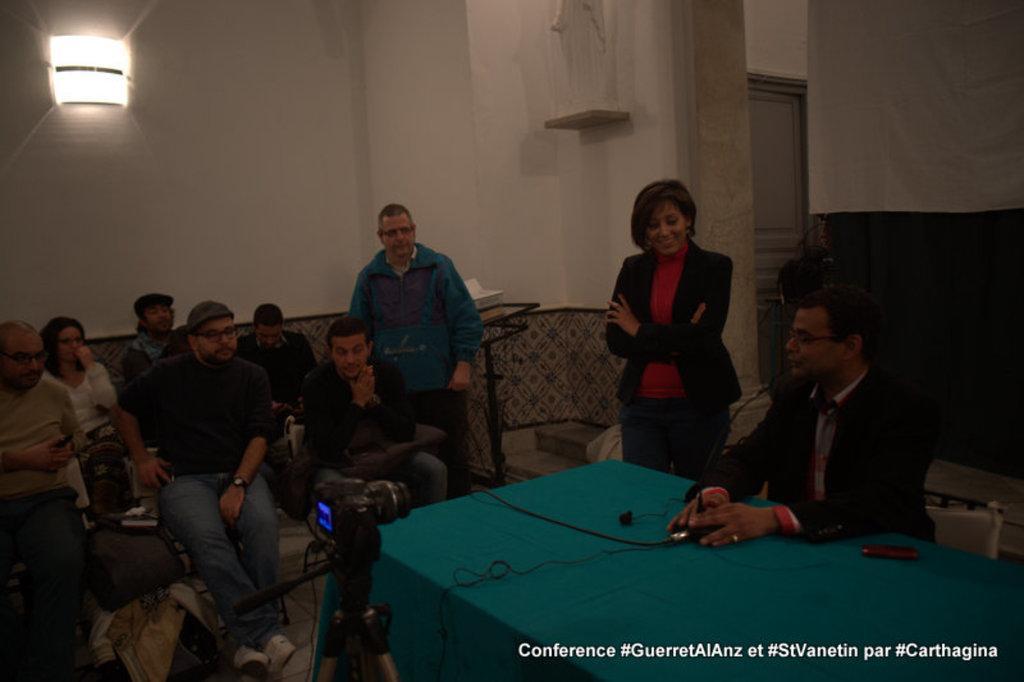Can you describe this image briefly? In this image I can see the group of people sitting and few people are standing. And there is a table in-front of one person. In the background there is a light and the wall. 